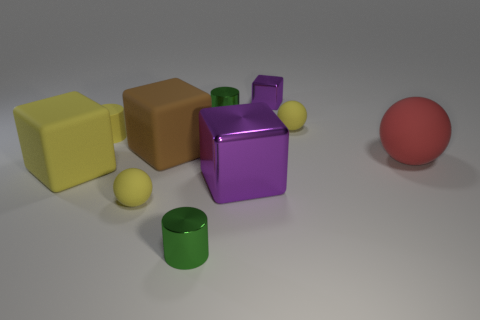What is the color of the thing that is left of the brown rubber thing and in front of the large purple object?
Offer a very short reply. Yellow. What number of big objects are either green metal cylinders or matte cylinders?
Make the answer very short. 0. There is a brown rubber thing that is the same shape as the big shiny thing; what is its size?
Offer a terse response. Large. What shape is the tiny purple thing?
Your response must be concise. Cube. Is the large brown cube made of the same material as the yellow object that is on the right side of the big purple cube?
Offer a very short reply. Yes. How many shiny objects are either purple cylinders or tiny yellow cylinders?
Offer a very short reply. 0. There is a purple cube that is in front of the large matte ball; what size is it?
Your answer should be very brief. Large. There is a purple block that is the same material as the small purple thing; what is its size?
Your answer should be compact. Large. How many rubber cylinders are the same color as the big metallic cube?
Make the answer very short. 0. Are any large balls visible?
Provide a succinct answer. Yes. 